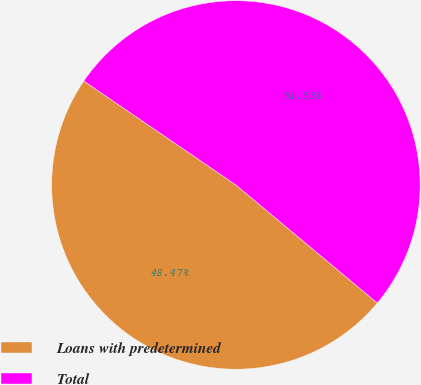Convert chart. <chart><loc_0><loc_0><loc_500><loc_500><pie_chart><fcel>Loans with predetermined<fcel>Total<nl><fcel>48.47%<fcel>51.53%<nl></chart> 